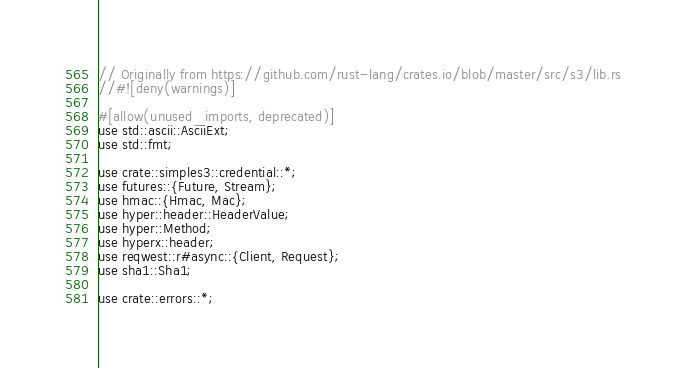Convert code to text. <code><loc_0><loc_0><loc_500><loc_500><_Rust_>// Originally from https://github.com/rust-lang/crates.io/blob/master/src/s3/lib.rs
//#![deny(warnings)]

#[allow(unused_imports, deprecated)]
use std::ascii::AsciiExt;
use std::fmt;

use crate::simples3::credential::*;
use futures::{Future, Stream};
use hmac::{Hmac, Mac};
use hyper::header::HeaderValue;
use hyper::Method;
use hyperx::header;
use reqwest::r#async::{Client, Request};
use sha1::Sha1;

use crate::errors::*;</code> 